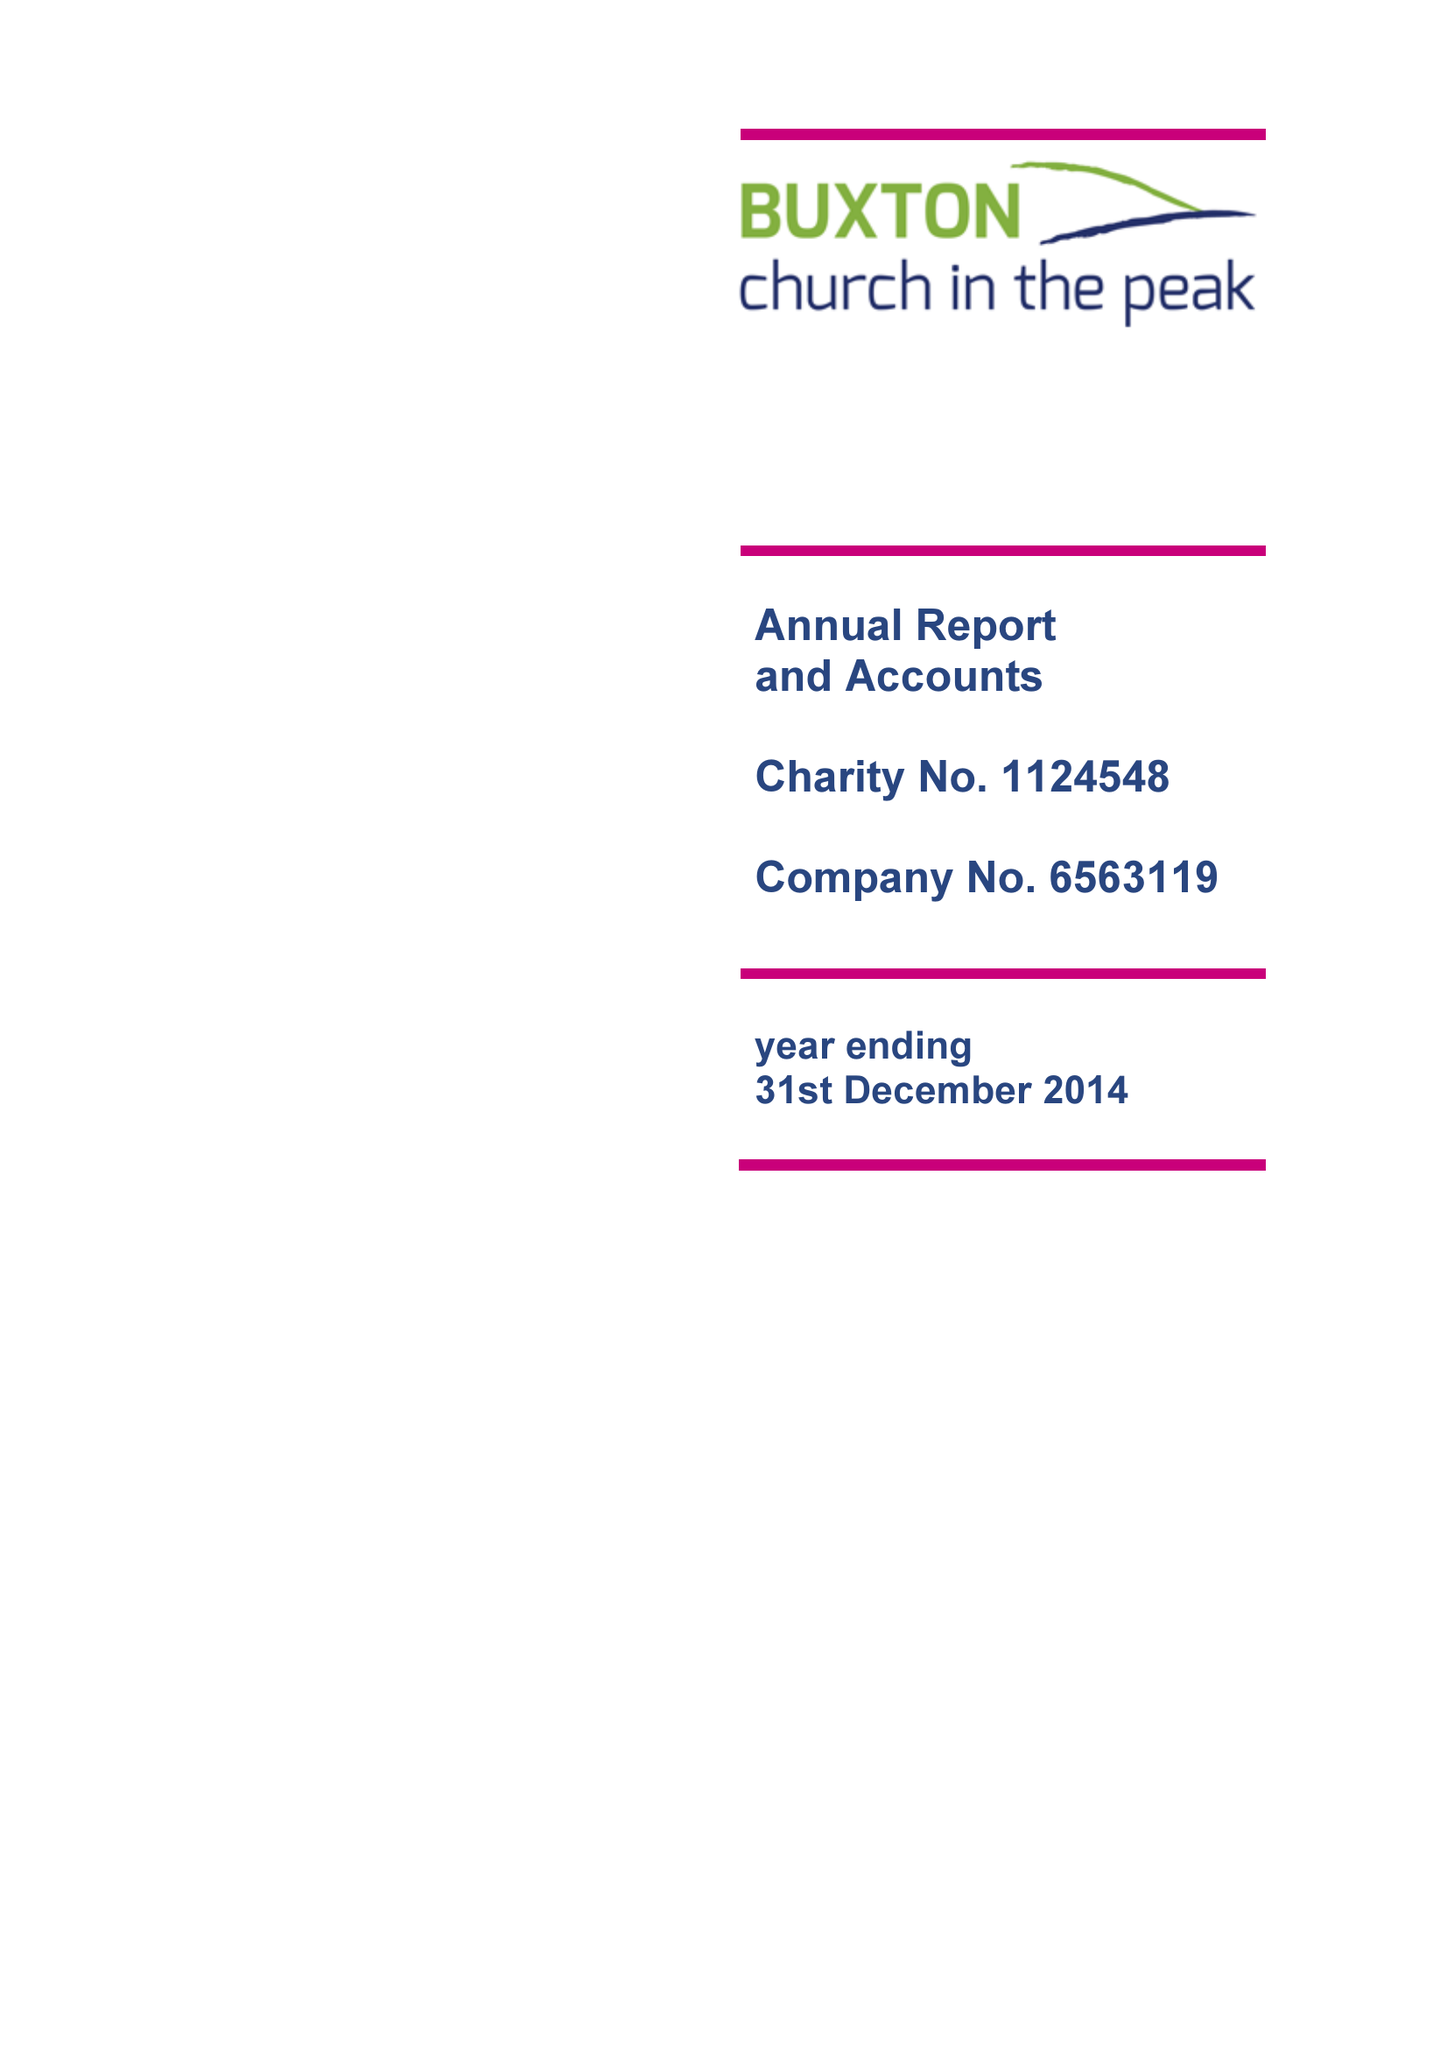What is the value for the income_annually_in_british_pounds?
Answer the question using a single word or phrase. 121078.00 